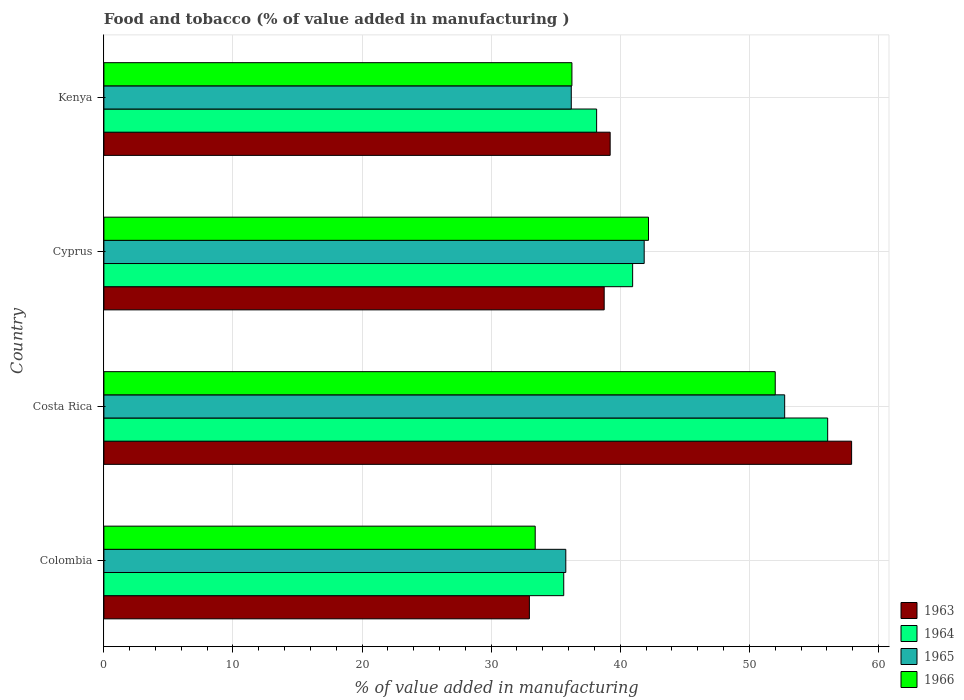How many different coloured bars are there?
Your response must be concise. 4. How many groups of bars are there?
Make the answer very short. 4. In how many cases, is the number of bars for a given country not equal to the number of legend labels?
Offer a very short reply. 0. What is the value added in manufacturing food and tobacco in 1964 in Cyprus?
Provide a short and direct response. 40.96. Across all countries, what is the maximum value added in manufacturing food and tobacco in 1964?
Offer a terse response. 56.07. Across all countries, what is the minimum value added in manufacturing food and tobacco in 1963?
Make the answer very short. 32.96. In which country was the value added in manufacturing food and tobacco in 1964 maximum?
Your answer should be compact. Costa Rica. What is the total value added in manufacturing food and tobacco in 1965 in the graph?
Provide a succinct answer. 166.57. What is the difference between the value added in manufacturing food and tobacco in 1965 in Costa Rica and that in Kenya?
Your answer should be very brief. 16.53. What is the difference between the value added in manufacturing food and tobacco in 1963 in Colombia and the value added in manufacturing food and tobacco in 1964 in Costa Rica?
Offer a very short reply. -23.11. What is the average value added in manufacturing food and tobacco in 1966 per country?
Give a very brief answer. 40.96. What is the difference between the value added in manufacturing food and tobacco in 1966 and value added in manufacturing food and tobacco in 1963 in Colombia?
Offer a terse response. 0.45. What is the ratio of the value added in manufacturing food and tobacco in 1963 in Costa Rica to that in Cyprus?
Make the answer very short. 1.49. Is the difference between the value added in manufacturing food and tobacco in 1966 in Cyprus and Kenya greater than the difference between the value added in manufacturing food and tobacco in 1963 in Cyprus and Kenya?
Make the answer very short. Yes. What is the difference between the highest and the second highest value added in manufacturing food and tobacco in 1966?
Your response must be concise. 9.82. What is the difference between the highest and the lowest value added in manufacturing food and tobacco in 1966?
Offer a very short reply. 18.59. Is the sum of the value added in manufacturing food and tobacco in 1964 in Cyprus and Kenya greater than the maximum value added in manufacturing food and tobacco in 1966 across all countries?
Offer a terse response. Yes. What does the 2nd bar from the top in Colombia represents?
Provide a short and direct response. 1965. What does the 3rd bar from the bottom in Colombia represents?
Give a very brief answer. 1965. How many bars are there?
Offer a terse response. 16. Are all the bars in the graph horizontal?
Your answer should be very brief. Yes. How many countries are there in the graph?
Your answer should be compact. 4. What is the difference between two consecutive major ticks on the X-axis?
Ensure brevity in your answer.  10. Are the values on the major ticks of X-axis written in scientific E-notation?
Your response must be concise. No. Does the graph contain any zero values?
Make the answer very short. No. Does the graph contain grids?
Offer a very short reply. Yes. Where does the legend appear in the graph?
Make the answer very short. Bottom right. What is the title of the graph?
Keep it short and to the point. Food and tobacco (% of value added in manufacturing ). Does "1995" appear as one of the legend labels in the graph?
Your answer should be very brief. No. What is the label or title of the X-axis?
Offer a very short reply. % of value added in manufacturing. What is the % of value added in manufacturing in 1963 in Colombia?
Provide a short and direct response. 32.96. What is the % of value added in manufacturing in 1964 in Colombia?
Ensure brevity in your answer.  35.62. What is the % of value added in manufacturing in 1965 in Colombia?
Your answer should be very brief. 35.78. What is the % of value added in manufacturing in 1966 in Colombia?
Provide a short and direct response. 33.41. What is the % of value added in manufacturing of 1963 in Costa Rica?
Your answer should be compact. 57.92. What is the % of value added in manufacturing in 1964 in Costa Rica?
Ensure brevity in your answer.  56.07. What is the % of value added in manufacturing of 1965 in Costa Rica?
Ensure brevity in your answer.  52.73. What is the % of value added in manufacturing in 1966 in Costa Rica?
Your answer should be compact. 52. What is the % of value added in manufacturing of 1963 in Cyprus?
Give a very brief answer. 38.75. What is the % of value added in manufacturing in 1964 in Cyprus?
Your answer should be compact. 40.96. What is the % of value added in manufacturing of 1965 in Cyprus?
Provide a succinct answer. 41.85. What is the % of value added in manufacturing in 1966 in Cyprus?
Offer a very short reply. 42.19. What is the % of value added in manufacturing in 1963 in Kenya?
Your answer should be compact. 39.22. What is the % of value added in manufacturing of 1964 in Kenya?
Offer a terse response. 38.17. What is the % of value added in manufacturing of 1965 in Kenya?
Ensure brevity in your answer.  36.2. What is the % of value added in manufacturing of 1966 in Kenya?
Ensure brevity in your answer.  36.25. Across all countries, what is the maximum % of value added in manufacturing in 1963?
Your answer should be compact. 57.92. Across all countries, what is the maximum % of value added in manufacturing of 1964?
Make the answer very short. 56.07. Across all countries, what is the maximum % of value added in manufacturing in 1965?
Offer a terse response. 52.73. Across all countries, what is the maximum % of value added in manufacturing in 1966?
Your answer should be compact. 52. Across all countries, what is the minimum % of value added in manufacturing in 1963?
Your answer should be compact. 32.96. Across all countries, what is the minimum % of value added in manufacturing in 1964?
Make the answer very short. 35.62. Across all countries, what is the minimum % of value added in manufacturing of 1965?
Make the answer very short. 35.78. Across all countries, what is the minimum % of value added in manufacturing of 1966?
Offer a terse response. 33.41. What is the total % of value added in manufacturing of 1963 in the graph?
Offer a very short reply. 168.85. What is the total % of value added in manufacturing in 1964 in the graph?
Ensure brevity in your answer.  170.81. What is the total % of value added in manufacturing in 1965 in the graph?
Keep it short and to the point. 166.57. What is the total % of value added in manufacturing in 1966 in the graph?
Ensure brevity in your answer.  163.86. What is the difference between the % of value added in manufacturing in 1963 in Colombia and that in Costa Rica?
Your answer should be very brief. -24.96. What is the difference between the % of value added in manufacturing in 1964 in Colombia and that in Costa Rica?
Offer a terse response. -20.45. What is the difference between the % of value added in manufacturing of 1965 in Colombia and that in Costa Rica?
Keep it short and to the point. -16.95. What is the difference between the % of value added in manufacturing in 1966 in Colombia and that in Costa Rica?
Provide a succinct answer. -18.59. What is the difference between the % of value added in manufacturing of 1963 in Colombia and that in Cyprus?
Your answer should be very brief. -5.79. What is the difference between the % of value added in manufacturing of 1964 in Colombia and that in Cyprus?
Give a very brief answer. -5.34. What is the difference between the % of value added in manufacturing in 1965 in Colombia and that in Cyprus?
Your response must be concise. -6.07. What is the difference between the % of value added in manufacturing of 1966 in Colombia and that in Cyprus?
Your response must be concise. -8.78. What is the difference between the % of value added in manufacturing in 1963 in Colombia and that in Kenya?
Offer a very short reply. -6.26. What is the difference between the % of value added in manufacturing of 1964 in Colombia and that in Kenya?
Keep it short and to the point. -2.55. What is the difference between the % of value added in manufacturing of 1965 in Colombia and that in Kenya?
Provide a succinct answer. -0.42. What is the difference between the % of value added in manufacturing of 1966 in Colombia and that in Kenya?
Your answer should be very brief. -2.84. What is the difference between the % of value added in manufacturing in 1963 in Costa Rica and that in Cyprus?
Your answer should be compact. 19.17. What is the difference between the % of value added in manufacturing in 1964 in Costa Rica and that in Cyprus?
Offer a terse response. 15.11. What is the difference between the % of value added in manufacturing of 1965 in Costa Rica and that in Cyprus?
Your response must be concise. 10.88. What is the difference between the % of value added in manufacturing in 1966 in Costa Rica and that in Cyprus?
Your response must be concise. 9.82. What is the difference between the % of value added in manufacturing in 1963 in Costa Rica and that in Kenya?
Make the answer very short. 18.7. What is the difference between the % of value added in manufacturing of 1964 in Costa Rica and that in Kenya?
Provide a succinct answer. 17.9. What is the difference between the % of value added in manufacturing of 1965 in Costa Rica and that in Kenya?
Make the answer very short. 16.53. What is the difference between the % of value added in manufacturing of 1966 in Costa Rica and that in Kenya?
Your response must be concise. 15.75. What is the difference between the % of value added in manufacturing of 1963 in Cyprus and that in Kenya?
Keep it short and to the point. -0.46. What is the difference between the % of value added in manufacturing of 1964 in Cyprus and that in Kenya?
Your response must be concise. 2.79. What is the difference between the % of value added in manufacturing of 1965 in Cyprus and that in Kenya?
Provide a succinct answer. 5.65. What is the difference between the % of value added in manufacturing of 1966 in Cyprus and that in Kenya?
Your response must be concise. 5.93. What is the difference between the % of value added in manufacturing in 1963 in Colombia and the % of value added in manufacturing in 1964 in Costa Rica?
Give a very brief answer. -23.11. What is the difference between the % of value added in manufacturing in 1963 in Colombia and the % of value added in manufacturing in 1965 in Costa Rica?
Provide a succinct answer. -19.77. What is the difference between the % of value added in manufacturing of 1963 in Colombia and the % of value added in manufacturing of 1966 in Costa Rica?
Your answer should be very brief. -19.04. What is the difference between the % of value added in manufacturing in 1964 in Colombia and the % of value added in manufacturing in 1965 in Costa Rica?
Your response must be concise. -17.11. What is the difference between the % of value added in manufacturing in 1964 in Colombia and the % of value added in manufacturing in 1966 in Costa Rica?
Give a very brief answer. -16.38. What is the difference between the % of value added in manufacturing in 1965 in Colombia and the % of value added in manufacturing in 1966 in Costa Rica?
Your response must be concise. -16.22. What is the difference between the % of value added in manufacturing in 1963 in Colombia and the % of value added in manufacturing in 1964 in Cyprus?
Your answer should be very brief. -8. What is the difference between the % of value added in manufacturing in 1963 in Colombia and the % of value added in manufacturing in 1965 in Cyprus?
Your answer should be very brief. -8.89. What is the difference between the % of value added in manufacturing of 1963 in Colombia and the % of value added in manufacturing of 1966 in Cyprus?
Offer a very short reply. -9.23. What is the difference between the % of value added in manufacturing in 1964 in Colombia and the % of value added in manufacturing in 1965 in Cyprus?
Ensure brevity in your answer.  -6.23. What is the difference between the % of value added in manufacturing in 1964 in Colombia and the % of value added in manufacturing in 1966 in Cyprus?
Offer a very short reply. -6.57. What is the difference between the % of value added in manufacturing of 1965 in Colombia and the % of value added in manufacturing of 1966 in Cyprus?
Your answer should be compact. -6.41. What is the difference between the % of value added in manufacturing of 1963 in Colombia and the % of value added in manufacturing of 1964 in Kenya?
Your answer should be very brief. -5.21. What is the difference between the % of value added in manufacturing of 1963 in Colombia and the % of value added in manufacturing of 1965 in Kenya?
Your answer should be compact. -3.24. What is the difference between the % of value added in manufacturing of 1963 in Colombia and the % of value added in manufacturing of 1966 in Kenya?
Keep it short and to the point. -3.29. What is the difference between the % of value added in manufacturing in 1964 in Colombia and the % of value added in manufacturing in 1965 in Kenya?
Make the answer very short. -0.58. What is the difference between the % of value added in manufacturing of 1964 in Colombia and the % of value added in manufacturing of 1966 in Kenya?
Offer a terse response. -0.63. What is the difference between the % of value added in manufacturing in 1965 in Colombia and the % of value added in manufacturing in 1966 in Kenya?
Offer a very short reply. -0.47. What is the difference between the % of value added in manufacturing of 1963 in Costa Rica and the % of value added in manufacturing of 1964 in Cyprus?
Your response must be concise. 16.96. What is the difference between the % of value added in manufacturing of 1963 in Costa Rica and the % of value added in manufacturing of 1965 in Cyprus?
Your answer should be very brief. 16.07. What is the difference between the % of value added in manufacturing of 1963 in Costa Rica and the % of value added in manufacturing of 1966 in Cyprus?
Keep it short and to the point. 15.73. What is the difference between the % of value added in manufacturing in 1964 in Costa Rica and the % of value added in manufacturing in 1965 in Cyprus?
Your answer should be very brief. 14.21. What is the difference between the % of value added in manufacturing in 1964 in Costa Rica and the % of value added in manufacturing in 1966 in Cyprus?
Provide a short and direct response. 13.88. What is the difference between the % of value added in manufacturing in 1965 in Costa Rica and the % of value added in manufacturing in 1966 in Cyprus?
Your answer should be very brief. 10.55. What is the difference between the % of value added in manufacturing in 1963 in Costa Rica and the % of value added in manufacturing in 1964 in Kenya?
Ensure brevity in your answer.  19.75. What is the difference between the % of value added in manufacturing in 1963 in Costa Rica and the % of value added in manufacturing in 1965 in Kenya?
Your answer should be very brief. 21.72. What is the difference between the % of value added in manufacturing in 1963 in Costa Rica and the % of value added in manufacturing in 1966 in Kenya?
Provide a short and direct response. 21.67. What is the difference between the % of value added in manufacturing in 1964 in Costa Rica and the % of value added in manufacturing in 1965 in Kenya?
Your answer should be very brief. 19.86. What is the difference between the % of value added in manufacturing in 1964 in Costa Rica and the % of value added in manufacturing in 1966 in Kenya?
Your response must be concise. 19.81. What is the difference between the % of value added in manufacturing of 1965 in Costa Rica and the % of value added in manufacturing of 1966 in Kenya?
Provide a short and direct response. 16.48. What is the difference between the % of value added in manufacturing in 1963 in Cyprus and the % of value added in manufacturing in 1964 in Kenya?
Your answer should be very brief. 0.59. What is the difference between the % of value added in manufacturing in 1963 in Cyprus and the % of value added in manufacturing in 1965 in Kenya?
Your answer should be very brief. 2.55. What is the difference between the % of value added in manufacturing in 1963 in Cyprus and the % of value added in manufacturing in 1966 in Kenya?
Offer a very short reply. 2.5. What is the difference between the % of value added in manufacturing of 1964 in Cyprus and the % of value added in manufacturing of 1965 in Kenya?
Offer a terse response. 4.75. What is the difference between the % of value added in manufacturing of 1964 in Cyprus and the % of value added in manufacturing of 1966 in Kenya?
Provide a succinct answer. 4.7. What is the difference between the % of value added in manufacturing in 1965 in Cyprus and the % of value added in manufacturing in 1966 in Kenya?
Make the answer very short. 5.6. What is the average % of value added in manufacturing of 1963 per country?
Ensure brevity in your answer.  42.21. What is the average % of value added in manufacturing of 1964 per country?
Provide a succinct answer. 42.7. What is the average % of value added in manufacturing in 1965 per country?
Provide a succinct answer. 41.64. What is the average % of value added in manufacturing in 1966 per country?
Provide a succinct answer. 40.96. What is the difference between the % of value added in manufacturing in 1963 and % of value added in manufacturing in 1964 in Colombia?
Offer a very short reply. -2.66. What is the difference between the % of value added in manufacturing in 1963 and % of value added in manufacturing in 1965 in Colombia?
Your answer should be compact. -2.82. What is the difference between the % of value added in manufacturing in 1963 and % of value added in manufacturing in 1966 in Colombia?
Provide a short and direct response. -0.45. What is the difference between the % of value added in manufacturing in 1964 and % of value added in manufacturing in 1965 in Colombia?
Provide a succinct answer. -0.16. What is the difference between the % of value added in manufacturing of 1964 and % of value added in manufacturing of 1966 in Colombia?
Your answer should be compact. 2.21. What is the difference between the % of value added in manufacturing of 1965 and % of value added in manufacturing of 1966 in Colombia?
Offer a terse response. 2.37. What is the difference between the % of value added in manufacturing in 1963 and % of value added in manufacturing in 1964 in Costa Rica?
Offer a very short reply. 1.85. What is the difference between the % of value added in manufacturing in 1963 and % of value added in manufacturing in 1965 in Costa Rica?
Provide a succinct answer. 5.19. What is the difference between the % of value added in manufacturing in 1963 and % of value added in manufacturing in 1966 in Costa Rica?
Offer a terse response. 5.92. What is the difference between the % of value added in manufacturing in 1964 and % of value added in manufacturing in 1965 in Costa Rica?
Give a very brief answer. 3.33. What is the difference between the % of value added in manufacturing of 1964 and % of value added in manufacturing of 1966 in Costa Rica?
Your response must be concise. 4.06. What is the difference between the % of value added in manufacturing of 1965 and % of value added in manufacturing of 1966 in Costa Rica?
Give a very brief answer. 0.73. What is the difference between the % of value added in manufacturing of 1963 and % of value added in manufacturing of 1964 in Cyprus?
Offer a terse response. -2.2. What is the difference between the % of value added in manufacturing in 1963 and % of value added in manufacturing in 1965 in Cyprus?
Offer a very short reply. -3.1. What is the difference between the % of value added in manufacturing in 1963 and % of value added in manufacturing in 1966 in Cyprus?
Make the answer very short. -3.43. What is the difference between the % of value added in manufacturing of 1964 and % of value added in manufacturing of 1965 in Cyprus?
Offer a terse response. -0.9. What is the difference between the % of value added in manufacturing in 1964 and % of value added in manufacturing in 1966 in Cyprus?
Give a very brief answer. -1.23. What is the difference between the % of value added in manufacturing in 1965 and % of value added in manufacturing in 1966 in Cyprus?
Provide a short and direct response. -0.33. What is the difference between the % of value added in manufacturing of 1963 and % of value added in manufacturing of 1964 in Kenya?
Provide a short and direct response. 1.05. What is the difference between the % of value added in manufacturing of 1963 and % of value added in manufacturing of 1965 in Kenya?
Offer a terse response. 3.01. What is the difference between the % of value added in manufacturing in 1963 and % of value added in manufacturing in 1966 in Kenya?
Your answer should be compact. 2.96. What is the difference between the % of value added in manufacturing in 1964 and % of value added in manufacturing in 1965 in Kenya?
Keep it short and to the point. 1.96. What is the difference between the % of value added in manufacturing of 1964 and % of value added in manufacturing of 1966 in Kenya?
Your answer should be very brief. 1.91. What is the ratio of the % of value added in manufacturing in 1963 in Colombia to that in Costa Rica?
Your response must be concise. 0.57. What is the ratio of the % of value added in manufacturing in 1964 in Colombia to that in Costa Rica?
Give a very brief answer. 0.64. What is the ratio of the % of value added in manufacturing in 1965 in Colombia to that in Costa Rica?
Offer a terse response. 0.68. What is the ratio of the % of value added in manufacturing in 1966 in Colombia to that in Costa Rica?
Offer a terse response. 0.64. What is the ratio of the % of value added in manufacturing in 1963 in Colombia to that in Cyprus?
Give a very brief answer. 0.85. What is the ratio of the % of value added in manufacturing in 1964 in Colombia to that in Cyprus?
Provide a short and direct response. 0.87. What is the ratio of the % of value added in manufacturing in 1965 in Colombia to that in Cyprus?
Offer a terse response. 0.85. What is the ratio of the % of value added in manufacturing of 1966 in Colombia to that in Cyprus?
Give a very brief answer. 0.79. What is the ratio of the % of value added in manufacturing in 1963 in Colombia to that in Kenya?
Provide a succinct answer. 0.84. What is the ratio of the % of value added in manufacturing of 1964 in Colombia to that in Kenya?
Offer a terse response. 0.93. What is the ratio of the % of value added in manufacturing of 1965 in Colombia to that in Kenya?
Your answer should be compact. 0.99. What is the ratio of the % of value added in manufacturing of 1966 in Colombia to that in Kenya?
Offer a very short reply. 0.92. What is the ratio of the % of value added in manufacturing of 1963 in Costa Rica to that in Cyprus?
Ensure brevity in your answer.  1.49. What is the ratio of the % of value added in manufacturing of 1964 in Costa Rica to that in Cyprus?
Make the answer very short. 1.37. What is the ratio of the % of value added in manufacturing of 1965 in Costa Rica to that in Cyprus?
Keep it short and to the point. 1.26. What is the ratio of the % of value added in manufacturing of 1966 in Costa Rica to that in Cyprus?
Ensure brevity in your answer.  1.23. What is the ratio of the % of value added in manufacturing in 1963 in Costa Rica to that in Kenya?
Ensure brevity in your answer.  1.48. What is the ratio of the % of value added in manufacturing of 1964 in Costa Rica to that in Kenya?
Offer a terse response. 1.47. What is the ratio of the % of value added in manufacturing of 1965 in Costa Rica to that in Kenya?
Keep it short and to the point. 1.46. What is the ratio of the % of value added in manufacturing of 1966 in Costa Rica to that in Kenya?
Offer a terse response. 1.43. What is the ratio of the % of value added in manufacturing in 1963 in Cyprus to that in Kenya?
Offer a very short reply. 0.99. What is the ratio of the % of value added in manufacturing in 1964 in Cyprus to that in Kenya?
Your response must be concise. 1.07. What is the ratio of the % of value added in manufacturing in 1965 in Cyprus to that in Kenya?
Your answer should be compact. 1.16. What is the ratio of the % of value added in manufacturing in 1966 in Cyprus to that in Kenya?
Your answer should be very brief. 1.16. What is the difference between the highest and the second highest % of value added in manufacturing in 1963?
Provide a succinct answer. 18.7. What is the difference between the highest and the second highest % of value added in manufacturing of 1964?
Ensure brevity in your answer.  15.11. What is the difference between the highest and the second highest % of value added in manufacturing of 1965?
Keep it short and to the point. 10.88. What is the difference between the highest and the second highest % of value added in manufacturing of 1966?
Offer a very short reply. 9.82. What is the difference between the highest and the lowest % of value added in manufacturing in 1963?
Give a very brief answer. 24.96. What is the difference between the highest and the lowest % of value added in manufacturing of 1964?
Keep it short and to the point. 20.45. What is the difference between the highest and the lowest % of value added in manufacturing of 1965?
Offer a very short reply. 16.95. What is the difference between the highest and the lowest % of value added in manufacturing of 1966?
Ensure brevity in your answer.  18.59. 